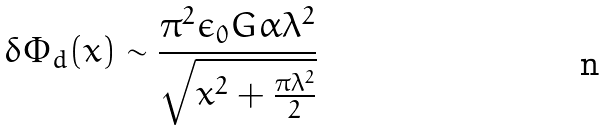<formula> <loc_0><loc_0><loc_500><loc_500>\delta \Phi _ { d } ( x ) \sim \frac { \pi ^ { 2 } \epsilon _ { 0 } G \alpha \lambda ^ { 2 } } { \sqrt { x ^ { 2 } + \frac { \pi \lambda ^ { 2 } } { 2 } } }</formula> 